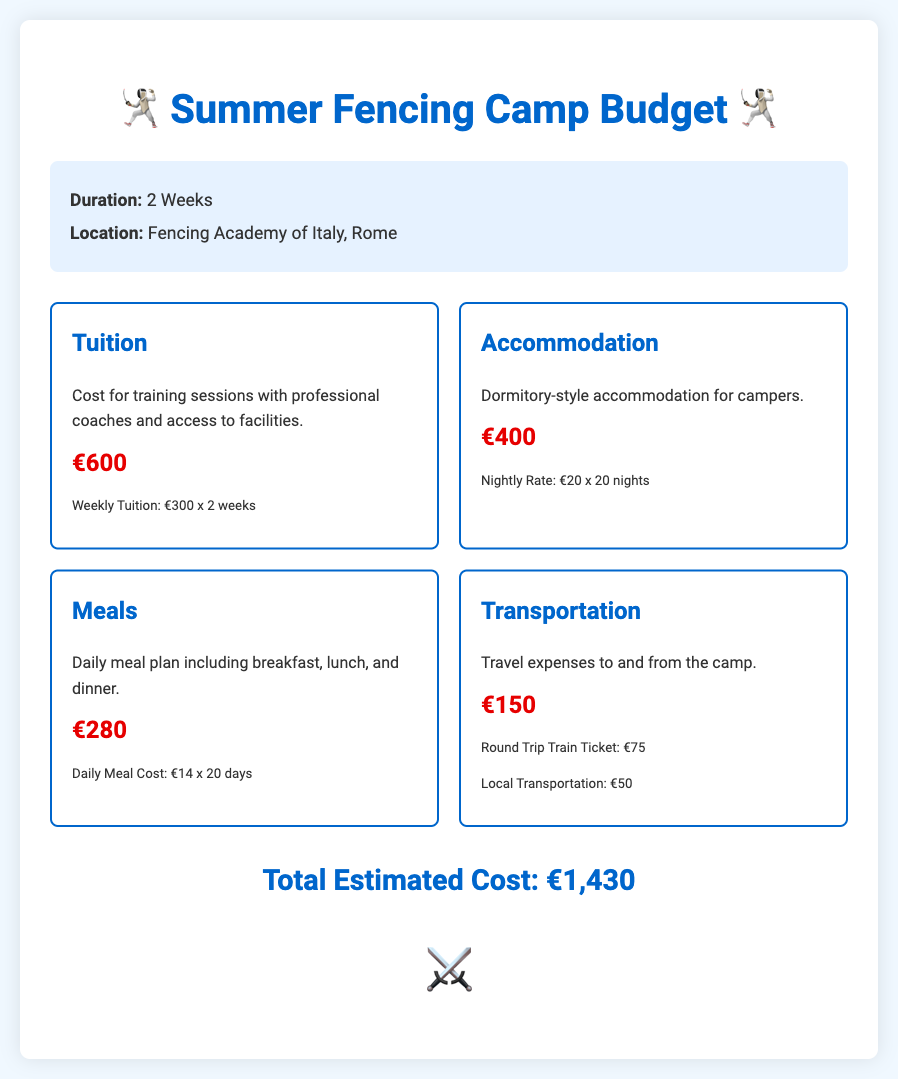What is the total estimated cost? The total estimated cost is presented at the bottom of the document, summing all categories.
Answer: €1,430 What is the cost of tuition? The tuition cost is listed clearly under the tuition category as the total amount for training sessions.
Answer: €600 How many nights is the accommodation calculated for? The accommodation cost is based on a nightly rate for a specific number of nights mentioned in the document.
Answer: 20 nights What is the daily meal cost? The daily meal cost is specified in the meals category, giving a breakdown for the total meal cost.
Answer: €14 How many weeks does the camp last? The duration of the camp is stated at the beginning of the document.
Answer: 2 Weeks What is the nightly rate for accommodation? The nightly rate for accommodation is provided in the accommodation section for clarity.
Answer: €20 What type of accommodation is provided? The type of accommodation is mentioned in the accommodation category, describing the lodging situation.
Answer: Dormitory-style What are the local transportation costs? Local transportation costs are included in the transportation section and listed separately.
Answer: €50 What city is the camp located in? The location of the camp is mentioned in the budget summary section.
Answer: Rome 